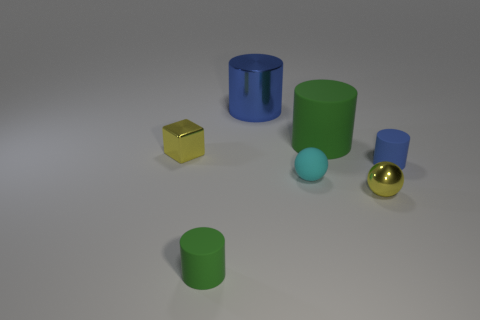How many other objects are there of the same material as the big blue cylinder?
Keep it short and to the point. 2. Are there any cyan matte balls on the left side of the large blue cylinder that is on the left side of the big cylinder in front of the metallic cylinder?
Provide a succinct answer. No. Are the tiny block and the tiny cyan ball made of the same material?
Give a very brief answer. No. Is there any other thing that is the same shape as the large green matte thing?
Your answer should be compact. Yes. There is a big object that is in front of the large cylinder on the left side of the big rubber cylinder; what is it made of?
Keep it short and to the point. Rubber. What is the size of the blue thing in front of the yellow block?
Make the answer very short. Small. The matte cylinder that is to the right of the tiny green object and in front of the tiny yellow cube is what color?
Make the answer very short. Blue. Do the green rubber object that is behind the yellow block and the large metallic cylinder have the same size?
Ensure brevity in your answer.  Yes. There is a big green rubber cylinder in front of the blue shiny object; are there any green objects that are to the right of it?
Your answer should be compact. No. What material is the big blue thing?
Your answer should be compact. Metal. 